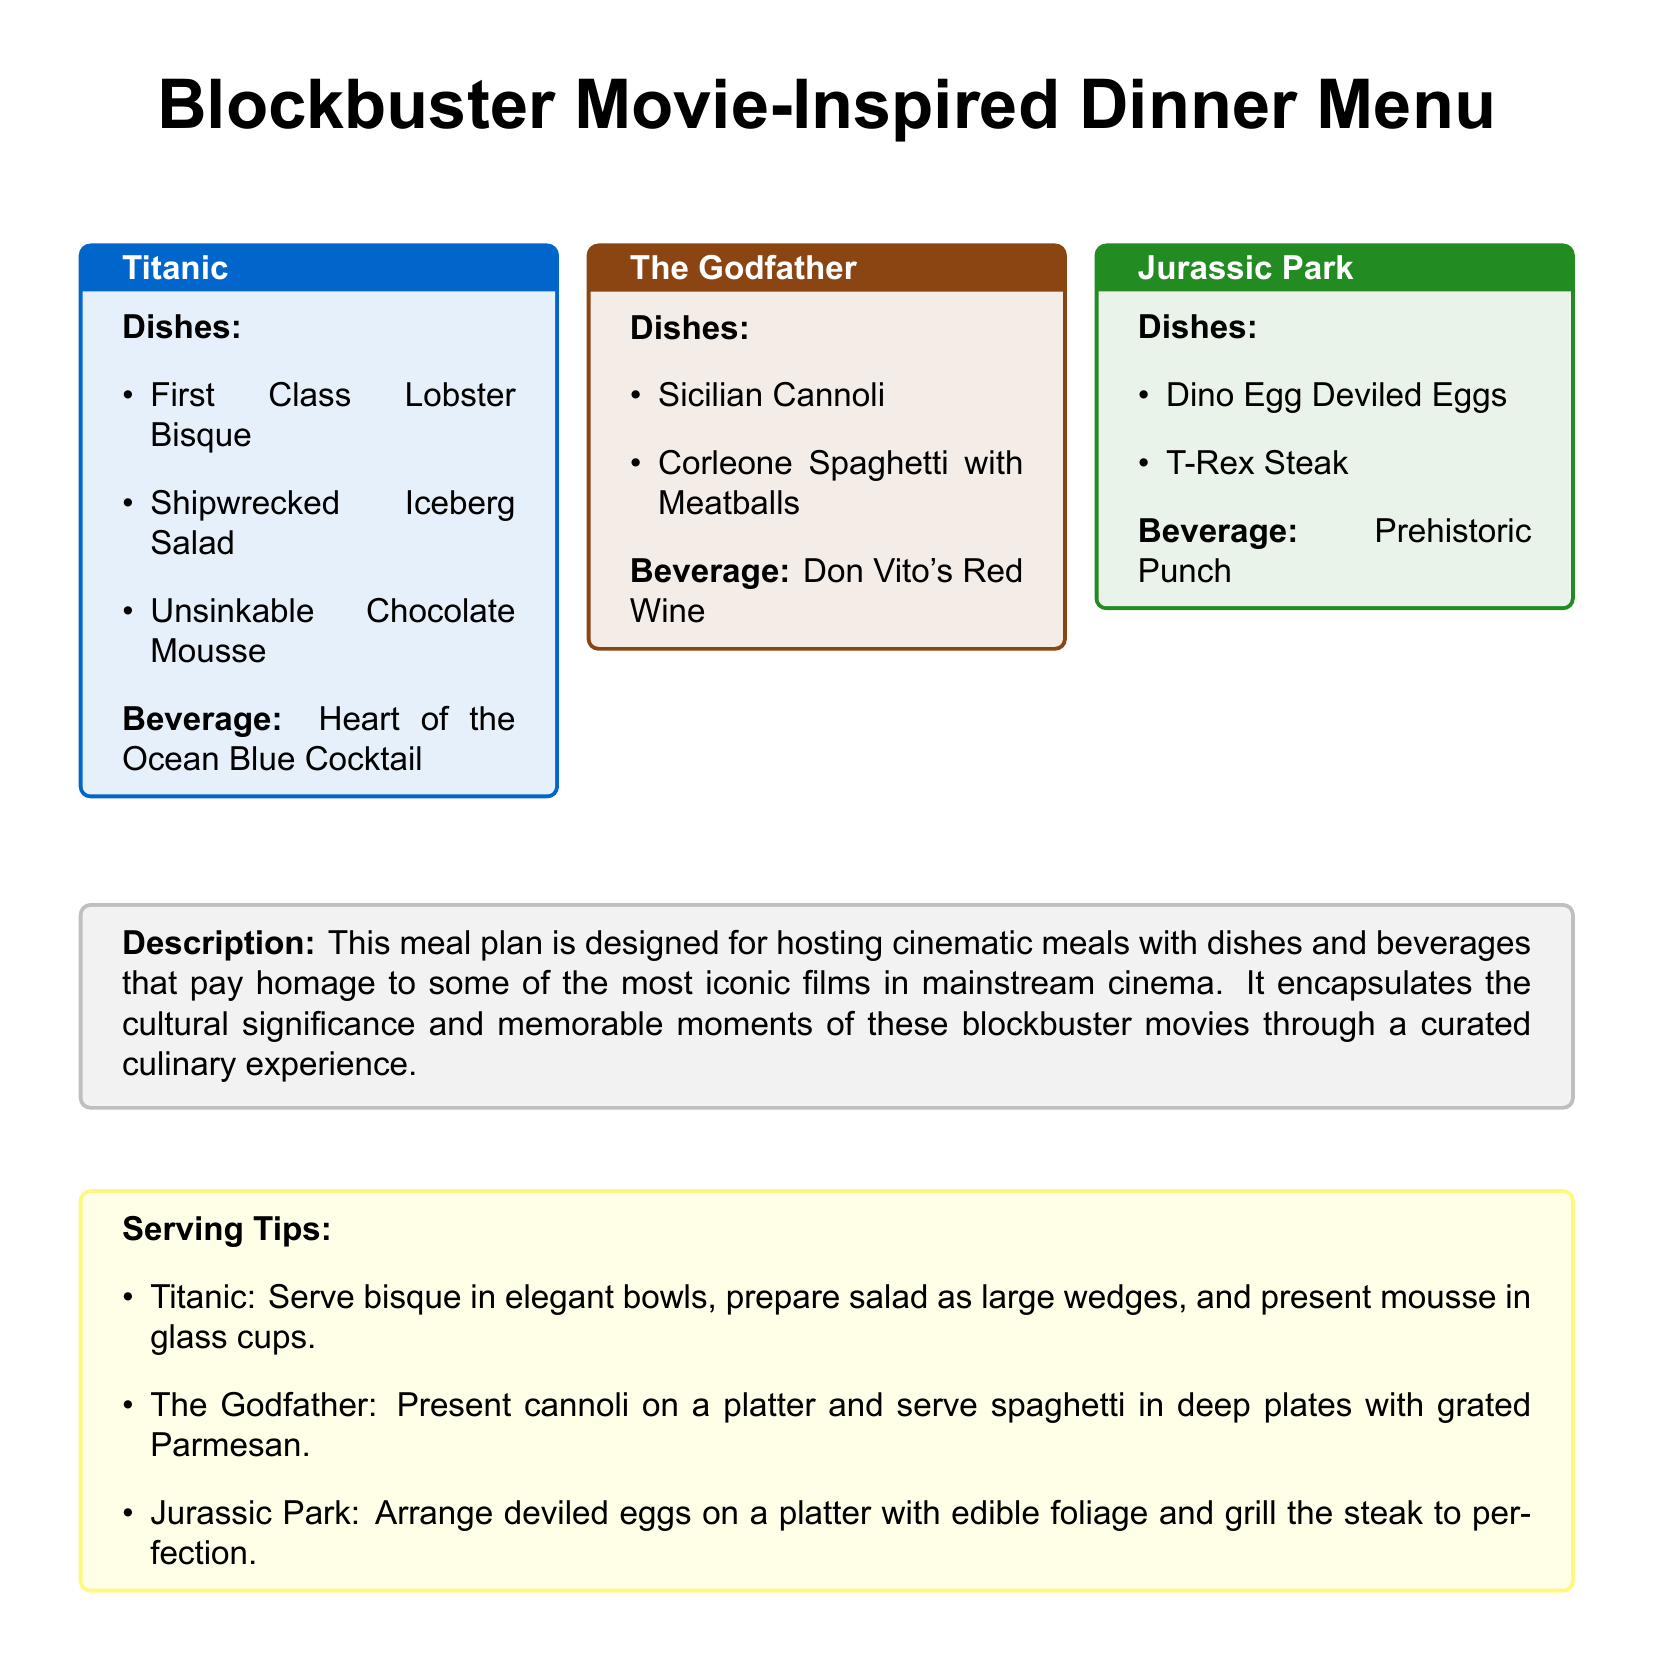What is the title of the meal plan? The title is presented at the top of the document and highlights the theme of the meal plan, which is "Blockbuster Movie-Inspired Dinner Menu."
Answer: Blockbuster Movie-Inspired Dinner Menu How many themed dinner menus are featured? The document features three themed dinner menus, each inspired by a different blockbuster movie.
Answer: 3 What drink is associated with Titanic? The drink related to Titanic is listed alongside the dishes and beverages for that theme.
Answer: Heart of the Ocean Blue Cocktail What dish is served in The Godfather theme? The Godfather theme includes specific dishes, and one is the iconic dessert that is highlighted.
Answer: Sicilian Cannoli Which movie inspired the Dino Egg Deviled Eggs? The document directly links specific dishes with their respective movie themes, including this playful name.
Answer: Jurassic Park What color is used for the Titanic box in the document? The Titanic themed box includes a specific color in the design details that enhances its presentation.
Answer: Blue What is one serving tip for Jurassic Park? The serving tips are provided to enhance the thematic dining experience and detail how to present dishes in line with the movie.
Answer: Arrange deviled eggs on a platter How is the T-Rex Steak suggested to be cooked? The document provides a recommendation for the preparation method of this dish to align with its theme.
Answer: Grill the steak to perfection What is the common theme of the meal plan? The overarching theme ties the dishes and beverages together in a unique culinary experience based on popular cinema.
Answer: Iconic films in mainstream cinema 